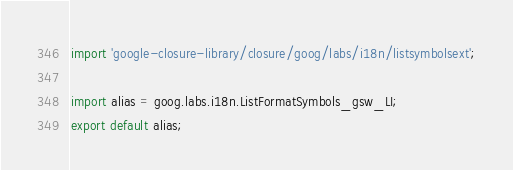<code> <loc_0><loc_0><loc_500><loc_500><_TypeScript_>import 'google-closure-library/closure/goog/labs/i18n/listsymbolsext';

import alias = goog.labs.i18n.ListFormatSymbols_gsw_LI;
export default alias;
</code> 